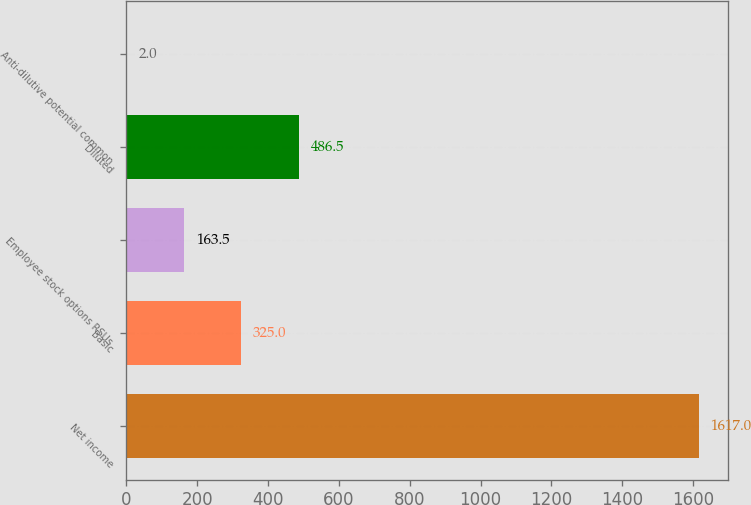Convert chart. <chart><loc_0><loc_0><loc_500><loc_500><bar_chart><fcel>Net income<fcel>Basic<fcel>Employee stock options RSUs<fcel>Diluted<fcel>Anti-dilutive potential common<nl><fcel>1617<fcel>325<fcel>163.5<fcel>486.5<fcel>2<nl></chart> 